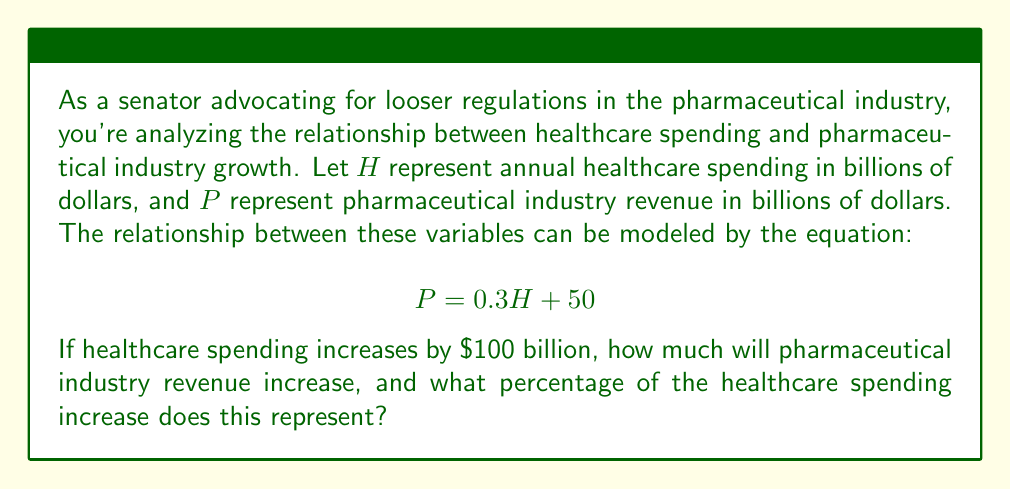Give your solution to this math problem. Let's approach this step-by-step:

1) First, we need to calculate the increase in pharmaceutical revenue when healthcare spending increases by $\$100$ billion.

2) We can do this by calculating the difference between P when H increases by 100:

   $P_{new} = 0.3(H + 100) + 50$
   $P_{old} = 0.3H + 50$

3) The increase in P is:

   $\Delta P = P_{new} - P_{old}$
   $= [0.3(H + 100) + 50] - [0.3H + 50]$
   $= 0.3H + 30 + 50 - 0.3H - 50$
   $= 30$ billion dollars

4) Now, to calculate what percentage this increase represents of the healthcare spending increase:

   Percentage = $\frac{\text{Increase in pharmaceutical revenue}}{\text{Increase in healthcare spending}} \times 100\%$
   
   $= \frac{30}{100} \times 100\% = 30\%$

5) This result aligns with the coefficient 0.3 in the original equation, which represents that 30% of healthcare spending goes to pharmaceutical revenue.
Answer: Pharmaceutical industry revenue will increase by $\$30$ billion, which represents 30% of the healthcare spending increase. 